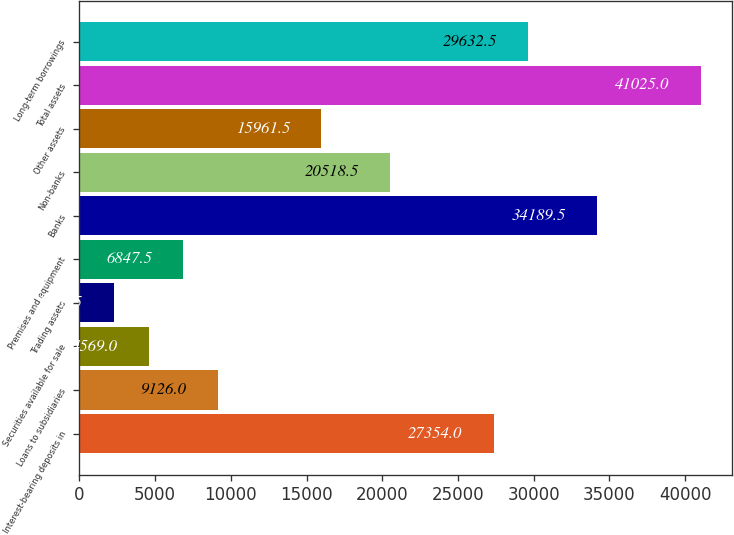Convert chart. <chart><loc_0><loc_0><loc_500><loc_500><bar_chart><fcel>Interest-bearing deposits in<fcel>Loans to subsidiaries<fcel>Securities available for sale<fcel>Trading assets<fcel>Premises and equipment<fcel>Banks<fcel>Non-banks<fcel>Other assets<fcel>Total assets<fcel>Long-term borrowings<nl><fcel>27354<fcel>9126<fcel>4569<fcel>2290.5<fcel>6847.5<fcel>34189.5<fcel>20518.5<fcel>15961.5<fcel>41025<fcel>29632.5<nl></chart> 